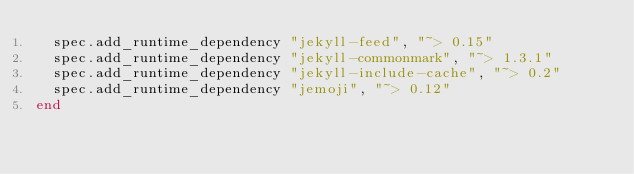Convert code to text. <code><loc_0><loc_0><loc_500><loc_500><_Ruby_>  spec.add_runtime_dependency "jekyll-feed", "~> 0.15"
  spec.add_runtime_dependency "jekyll-commonmark", "~> 1.3.1"
  spec.add_runtime_dependency "jekyll-include-cache", "~> 0.2"
  spec.add_runtime_dependency "jemoji", "~> 0.12"
end
</code> 